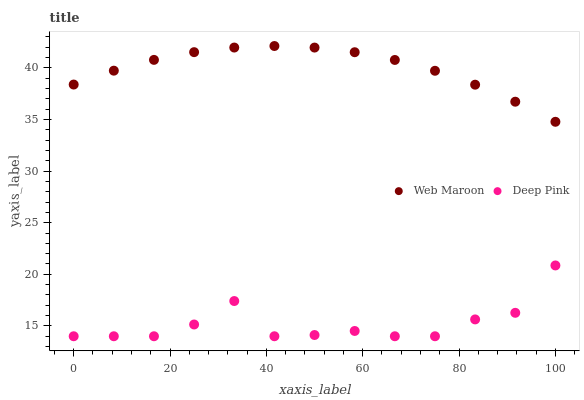Does Deep Pink have the minimum area under the curve?
Answer yes or no. Yes. Does Web Maroon have the maximum area under the curve?
Answer yes or no. Yes. Does Web Maroon have the minimum area under the curve?
Answer yes or no. No. Is Web Maroon the smoothest?
Answer yes or no. Yes. Is Deep Pink the roughest?
Answer yes or no. Yes. Is Web Maroon the roughest?
Answer yes or no. No. Does Deep Pink have the lowest value?
Answer yes or no. Yes. Does Web Maroon have the lowest value?
Answer yes or no. No. Does Web Maroon have the highest value?
Answer yes or no. Yes. Is Deep Pink less than Web Maroon?
Answer yes or no. Yes. Is Web Maroon greater than Deep Pink?
Answer yes or no. Yes. Does Deep Pink intersect Web Maroon?
Answer yes or no. No. 